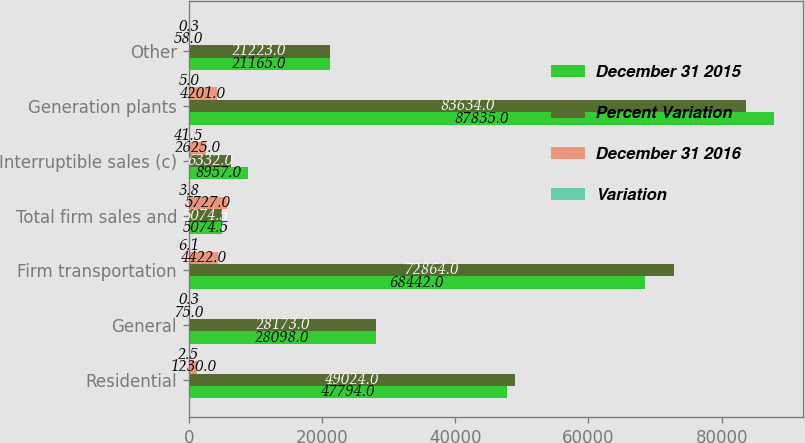Convert chart. <chart><loc_0><loc_0><loc_500><loc_500><stacked_bar_chart><ecel><fcel>Residential<fcel>General<fcel>Firm transportation<fcel>Total firm sales and<fcel>Interruptible sales (c)<fcel>Generation plants<fcel>Other<nl><fcel>December 31 2015<fcel>47794<fcel>28098<fcel>68442<fcel>5074.5<fcel>8957<fcel>87835<fcel>21165<nl><fcel>Percent Variation<fcel>49024<fcel>28173<fcel>72864<fcel>5074.5<fcel>6332<fcel>83634<fcel>21223<nl><fcel>December 31 2016<fcel>1230<fcel>75<fcel>4422<fcel>5727<fcel>2625<fcel>4201<fcel>58<nl><fcel>Variation<fcel>2.5<fcel>0.3<fcel>6.1<fcel>3.8<fcel>41.5<fcel>5<fcel>0.3<nl></chart> 